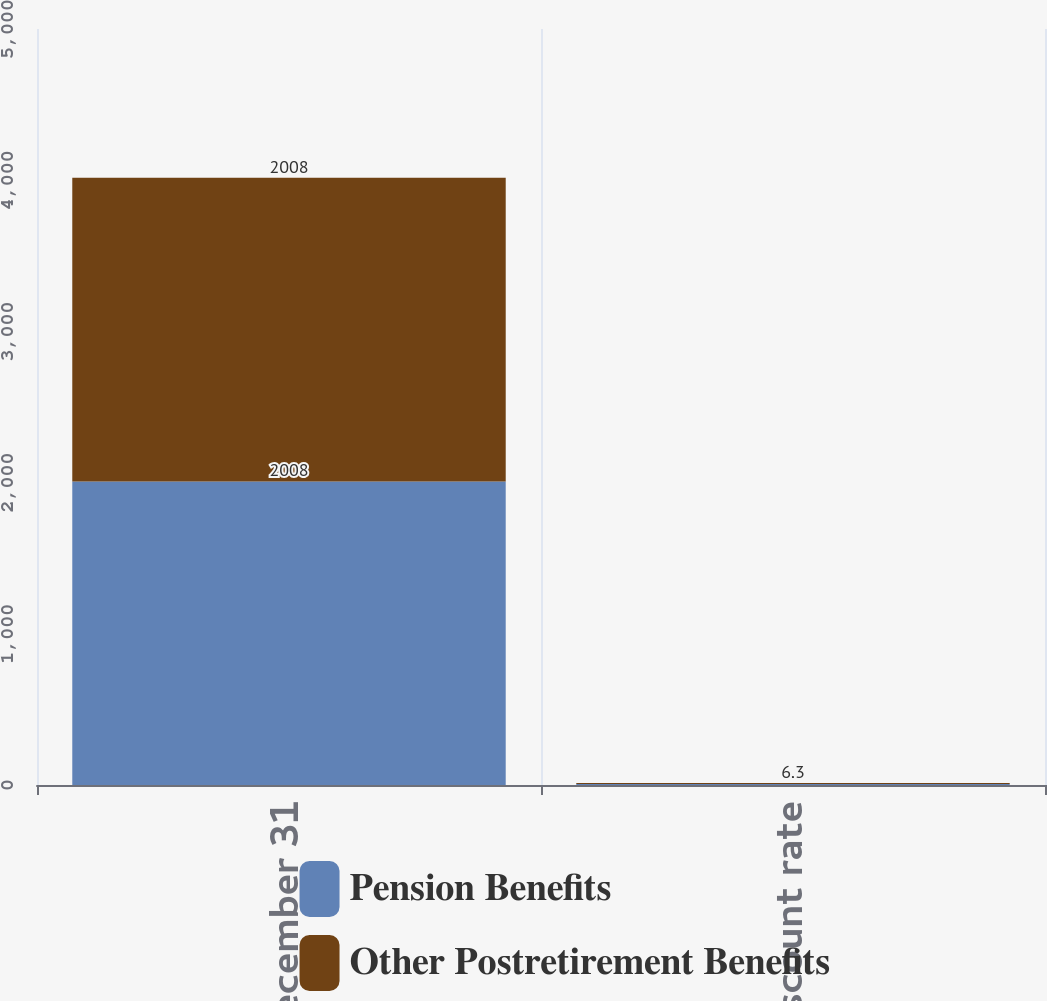<chart> <loc_0><loc_0><loc_500><loc_500><stacked_bar_chart><ecel><fcel>December 31<fcel>Discount rate<nl><fcel>Pension Benefits<fcel>2008<fcel>6.3<nl><fcel>Other Postretirement Benefits<fcel>2008<fcel>6.3<nl></chart> 